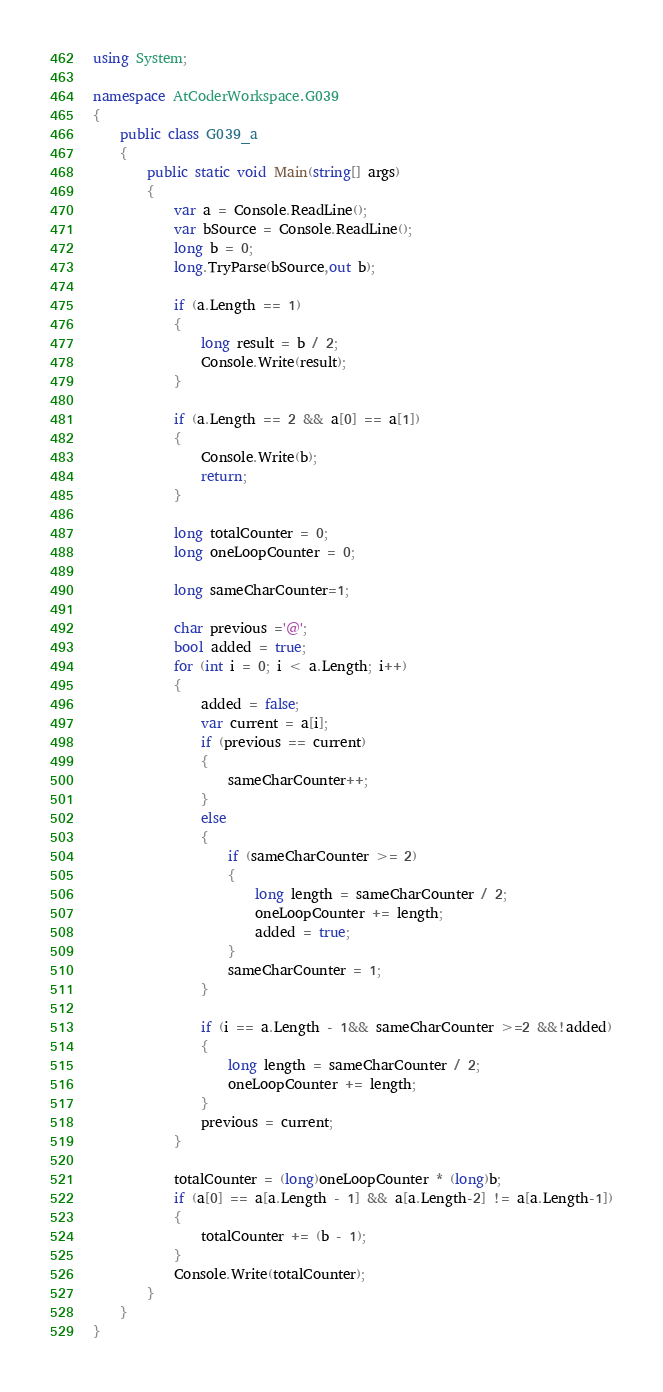<code> <loc_0><loc_0><loc_500><loc_500><_C#_>using System;

namespace AtCoderWorkspace.G039
{
    public class G039_a
    {
        public static void Main(string[] args)
        {
            var a = Console.ReadLine();
            var bSource = Console.ReadLine();
            long b = 0;
            long.TryParse(bSource,out b);

            if (a.Length == 1)
            {
                long result = b / 2;
                Console.Write(result);
            }

            if (a.Length == 2 && a[0] == a[1])
            {
                Console.Write(b);
                return;
            }

            long totalCounter = 0;
            long oneLoopCounter = 0;
            
            long sameCharCounter=1;
            
            char previous ='@';
            bool added = true;
            for (int i = 0; i < a.Length; i++)
            {
                added = false;
                var current = a[i];
                if (previous == current)
                {
                    sameCharCounter++;
                }
                else
                {
                    if (sameCharCounter >= 2)
                    {
                        long length = sameCharCounter / 2;
                        oneLoopCounter += length;
                        added = true;
                    }
                    sameCharCounter = 1;
                }
                
                if (i == a.Length - 1&& sameCharCounter >=2 &&!added)
                {
                    long length = sameCharCounter / 2;
                    oneLoopCounter += length;
                }
                previous = current;
            }

            totalCounter = (long)oneLoopCounter * (long)b;
            if (a[0] == a[a.Length - 1] && a[a.Length-2] != a[a.Length-1])
            {
                totalCounter += (b - 1);
            }
            Console.Write(totalCounter);
        }
    }
}</code> 